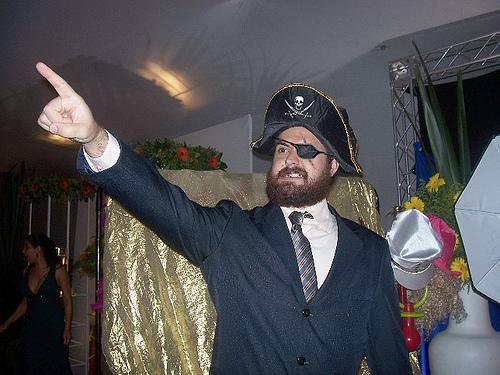If you had to guess which holiday would this most likely be? Please explain your reasoning. halloween. The holiday is halloween. 